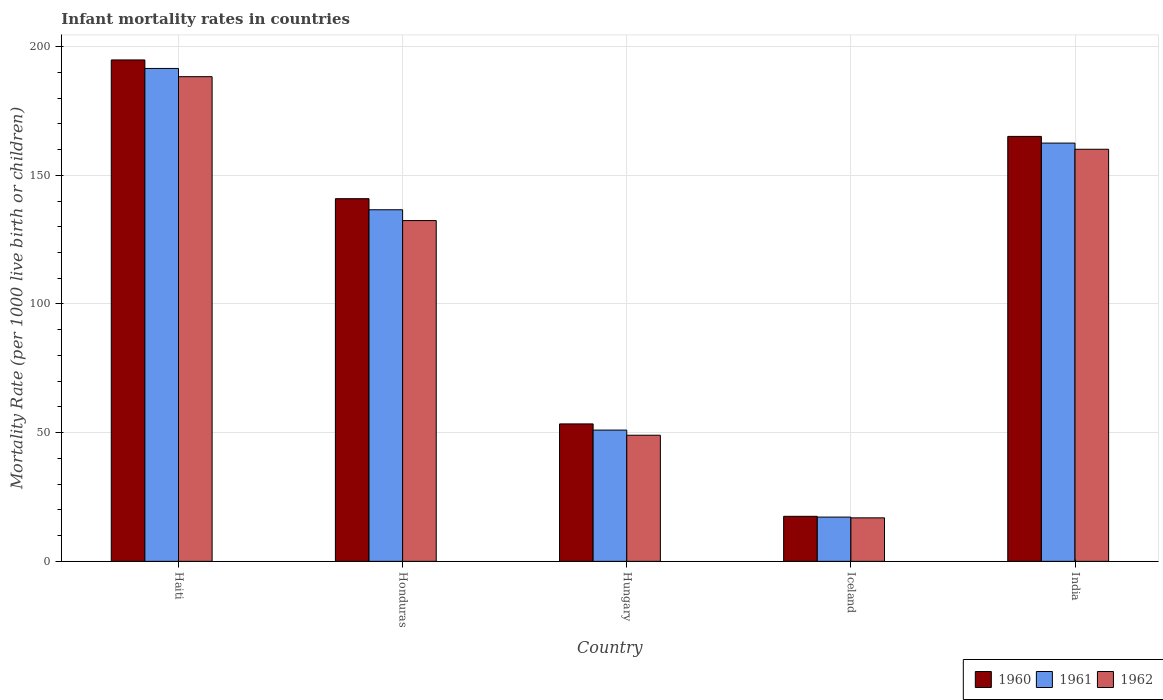How many groups of bars are there?
Offer a terse response. 5. Are the number of bars per tick equal to the number of legend labels?
Make the answer very short. Yes. Are the number of bars on each tick of the X-axis equal?
Ensure brevity in your answer.  Yes. How many bars are there on the 5th tick from the left?
Give a very brief answer. 3. What is the label of the 1st group of bars from the left?
Keep it short and to the point. Haiti. What is the infant mortality rate in 1961 in India?
Your answer should be very brief. 162.5. Across all countries, what is the maximum infant mortality rate in 1962?
Offer a very short reply. 188.3. In which country was the infant mortality rate in 1960 maximum?
Your answer should be compact. Haiti. In which country was the infant mortality rate in 1961 minimum?
Your response must be concise. Iceland. What is the total infant mortality rate in 1960 in the graph?
Your answer should be very brief. 571.7. What is the difference between the infant mortality rate in 1960 in Honduras and that in India?
Keep it short and to the point. -24.2. What is the difference between the infant mortality rate in 1960 in Hungary and the infant mortality rate in 1961 in Iceland?
Ensure brevity in your answer.  36.2. What is the average infant mortality rate in 1960 per country?
Make the answer very short. 114.34. What is the difference between the infant mortality rate of/in 1960 and infant mortality rate of/in 1961 in Hungary?
Make the answer very short. 2.4. In how many countries, is the infant mortality rate in 1961 greater than 70?
Ensure brevity in your answer.  3. What is the ratio of the infant mortality rate in 1961 in Haiti to that in Hungary?
Provide a succinct answer. 3.75. Is the infant mortality rate in 1962 in Hungary less than that in Iceland?
Provide a succinct answer. No. What is the difference between the highest and the second highest infant mortality rate in 1961?
Keep it short and to the point. -25.9. What is the difference between the highest and the lowest infant mortality rate in 1961?
Give a very brief answer. 174.3. Is the sum of the infant mortality rate in 1961 in Iceland and India greater than the maximum infant mortality rate in 1962 across all countries?
Keep it short and to the point. No. What does the 3rd bar from the left in Iceland represents?
Offer a very short reply. 1962. What does the 3rd bar from the right in Hungary represents?
Offer a very short reply. 1960. Is it the case that in every country, the sum of the infant mortality rate in 1961 and infant mortality rate in 1962 is greater than the infant mortality rate in 1960?
Your response must be concise. Yes. How many bars are there?
Your answer should be compact. 15. What is the difference between two consecutive major ticks on the Y-axis?
Make the answer very short. 50. Does the graph contain grids?
Provide a short and direct response. Yes. Where does the legend appear in the graph?
Make the answer very short. Bottom right. What is the title of the graph?
Offer a terse response. Infant mortality rates in countries. Does "2008" appear as one of the legend labels in the graph?
Keep it short and to the point. No. What is the label or title of the Y-axis?
Keep it short and to the point. Mortality Rate (per 1000 live birth or children). What is the Mortality Rate (per 1000 live birth or children) in 1960 in Haiti?
Your answer should be compact. 194.8. What is the Mortality Rate (per 1000 live birth or children) in 1961 in Haiti?
Ensure brevity in your answer.  191.5. What is the Mortality Rate (per 1000 live birth or children) of 1962 in Haiti?
Provide a short and direct response. 188.3. What is the Mortality Rate (per 1000 live birth or children) in 1960 in Honduras?
Provide a short and direct response. 140.9. What is the Mortality Rate (per 1000 live birth or children) of 1961 in Honduras?
Give a very brief answer. 136.6. What is the Mortality Rate (per 1000 live birth or children) in 1962 in Honduras?
Offer a very short reply. 132.4. What is the Mortality Rate (per 1000 live birth or children) in 1960 in Hungary?
Ensure brevity in your answer.  53.4. What is the Mortality Rate (per 1000 live birth or children) in 1961 in Hungary?
Ensure brevity in your answer.  51. What is the Mortality Rate (per 1000 live birth or children) in 1962 in Hungary?
Your answer should be very brief. 49. What is the Mortality Rate (per 1000 live birth or children) in 1960 in Iceland?
Provide a succinct answer. 17.5. What is the Mortality Rate (per 1000 live birth or children) in 1961 in Iceland?
Ensure brevity in your answer.  17.2. What is the Mortality Rate (per 1000 live birth or children) of 1962 in Iceland?
Your response must be concise. 16.9. What is the Mortality Rate (per 1000 live birth or children) in 1960 in India?
Your answer should be compact. 165.1. What is the Mortality Rate (per 1000 live birth or children) of 1961 in India?
Ensure brevity in your answer.  162.5. What is the Mortality Rate (per 1000 live birth or children) of 1962 in India?
Your answer should be compact. 160.1. Across all countries, what is the maximum Mortality Rate (per 1000 live birth or children) of 1960?
Offer a terse response. 194.8. Across all countries, what is the maximum Mortality Rate (per 1000 live birth or children) in 1961?
Make the answer very short. 191.5. Across all countries, what is the maximum Mortality Rate (per 1000 live birth or children) of 1962?
Offer a very short reply. 188.3. Across all countries, what is the minimum Mortality Rate (per 1000 live birth or children) in 1960?
Provide a short and direct response. 17.5. Across all countries, what is the minimum Mortality Rate (per 1000 live birth or children) of 1961?
Provide a succinct answer. 17.2. Across all countries, what is the minimum Mortality Rate (per 1000 live birth or children) in 1962?
Keep it short and to the point. 16.9. What is the total Mortality Rate (per 1000 live birth or children) in 1960 in the graph?
Keep it short and to the point. 571.7. What is the total Mortality Rate (per 1000 live birth or children) of 1961 in the graph?
Keep it short and to the point. 558.8. What is the total Mortality Rate (per 1000 live birth or children) of 1962 in the graph?
Keep it short and to the point. 546.7. What is the difference between the Mortality Rate (per 1000 live birth or children) of 1960 in Haiti and that in Honduras?
Make the answer very short. 53.9. What is the difference between the Mortality Rate (per 1000 live birth or children) in 1961 in Haiti and that in Honduras?
Make the answer very short. 54.9. What is the difference between the Mortality Rate (per 1000 live birth or children) in 1962 in Haiti and that in Honduras?
Your answer should be very brief. 55.9. What is the difference between the Mortality Rate (per 1000 live birth or children) of 1960 in Haiti and that in Hungary?
Offer a very short reply. 141.4. What is the difference between the Mortality Rate (per 1000 live birth or children) in 1961 in Haiti and that in Hungary?
Provide a succinct answer. 140.5. What is the difference between the Mortality Rate (per 1000 live birth or children) of 1962 in Haiti and that in Hungary?
Offer a very short reply. 139.3. What is the difference between the Mortality Rate (per 1000 live birth or children) in 1960 in Haiti and that in Iceland?
Keep it short and to the point. 177.3. What is the difference between the Mortality Rate (per 1000 live birth or children) in 1961 in Haiti and that in Iceland?
Give a very brief answer. 174.3. What is the difference between the Mortality Rate (per 1000 live birth or children) of 1962 in Haiti and that in Iceland?
Provide a short and direct response. 171.4. What is the difference between the Mortality Rate (per 1000 live birth or children) in 1960 in Haiti and that in India?
Offer a terse response. 29.7. What is the difference between the Mortality Rate (per 1000 live birth or children) of 1961 in Haiti and that in India?
Offer a terse response. 29. What is the difference between the Mortality Rate (per 1000 live birth or children) in 1962 in Haiti and that in India?
Your answer should be compact. 28.2. What is the difference between the Mortality Rate (per 1000 live birth or children) in 1960 in Honduras and that in Hungary?
Offer a terse response. 87.5. What is the difference between the Mortality Rate (per 1000 live birth or children) in 1961 in Honduras and that in Hungary?
Your answer should be compact. 85.6. What is the difference between the Mortality Rate (per 1000 live birth or children) in 1962 in Honduras and that in Hungary?
Keep it short and to the point. 83.4. What is the difference between the Mortality Rate (per 1000 live birth or children) of 1960 in Honduras and that in Iceland?
Make the answer very short. 123.4. What is the difference between the Mortality Rate (per 1000 live birth or children) in 1961 in Honduras and that in Iceland?
Give a very brief answer. 119.4. What is the difference between the Mortality Rate (per 1000 live birth or children) of 1962 in Honduras and that in Iceland?
Keep it short and to the point. 115.5. What is the difference between the Mortality Rate (per 1000 live birth or children) in 1960 in Honduras and that in India?
Offer a terse response. -24.2. What is the difference between the Mortality Rate (per 1000 live birth or children) of 1961 in Honduras and that in India?
Your answer should be compact. -25.9. What is the difference between the Mortality Rate (per 1000 live birth or children) of 1962 in Honduras and that in India?
Ensure brevity in your answer.  -27.7. What is the difference between the Mortality Rate (per 1000 live birth or children) of 1960 in Hungary and that in Iceland?
Ensure brevity in your answer.  35.9. What is the difference between the Mortality Rate (per 1000 live birth or children) of 1961 in Hungary and that in Iceland?
Ensure brevity in your answer.  33.8. What is the difference between the Mortality Rate (per 1000 live birth or children) of 1962 in Hungary and that in Iceland?
Give a very brief answer. 32.1. What is the difference between the Mortality Rate (per 1000 live birth or children) of 1960 in Hungary and that in India?
Your answer should be compact. -111.7. What is the difference between the Mortality Rate (per 1000 live birth or children) of 1961 in Hungary and that in India?
Your answer should be very brief. -111.5. What is the difference between the Mortality Rate (per 1000 live birth or children) of 1962 in Hungary and that in India?
Ensure brevity in your answer.  -111.1. What is the difference between the Mortality Rate (per 1000 live birth or children) in 1960 in Iceland and that in India?
Keep it short and to the point. -147.6. What is the difference between the Mortality Rate (per 1000 live birth or children) in 1961 in Iceland and that in India?
Give a very brief answer. -145.3. What is the difference between the Mortality Rate (per 1000 live birth or children) in 1962 in Iceland and that in India?
Provide a succinct answer. -143.2. What is the difference between the Mortality Rate (per 1000 live birth or children) of 1960 in Haiti and the Mortality Rate (per 1000 live birth or children) of 1961 in Honduras?
Give a very brief answer. 58.2. What is the difference between the Mortality Rate (per 1000 live birth or children) in 1960 in Haiti and the Mortality Rate (per 1000 live birth or children) in 1962 in Honduras?
Make the answer very short. 62.4. What is the difference between the Mortality Rate (per 1000 live birth or children) in 1961 in Haiti and the Mortality Rate (per 1000 live birth or children) in 1962 in Honduras?
Offer a very short reply. 59.1. What is the difference between the Mortality Rate (per 1000 live birth or children) in 1960 in Haiti and the Mortality Rate (per 1000 live birth or children) in 1961 in Hungary?
Offer a very short reply. 143.8. What is the difference between the Mortality Rate (per 1000 live birth or children) in 1960 in Haiti and the Mortality Rate (per 1000 live birth or children) in 1962 in Hungary?
Your answer should be very brief. 145.8. What is the difference between the Mortality Rate (per 1000 live birth or children) in 1961 in Haiti and the Mortality Rate (per 1000 live birth or children) in 1962 in Hungary?
Offer a terse response. 142.5. What is the difference between the Mortality Rate (per 1000 live birth or children) of 1960 in Haiti and the Mortality Rate (per 1000 live birth or children) of 1961 in Iceland?
Make the answer very short. 177.6. What is the difference between the Mortality Rate (per 1000 live birth or children) in 1960 in Haiti and the Mortality Rate (per 1000 live birth or children) in 1962 in Iceland?
Keep it short and to the point. 177.9. What is the difference between the Mortality Rate (per 1000 live birth or children) of 1961 in Haiti and the Mortality Rate (per 1000 live birth or children) of 1962 in Iceland?
Your answer should be compact. 174.6. What is the difference between the Mortality Rate (per 1000 live birth or children) of 1960 in Haiti and the Mortality Rate (per 1000 live birth or children) of 1961 in India?
Provide a succinct answer. 32.3. What is the difference between the Mortality Rate (per 1000 live birth or children) in 1960 in Haiti and the Mortality Rate (per 1000 live birth or children) in 1962 in India?
Provide a short and direct response. 34.7. What is the difference between the Mortality Rate (per 1000 live birth or children) of 1961 in Haiti and the Mortality Rate (per 1000 live birth or children) of 1962 in India?
Give a very brief answer. 31.4. What is the difference between the Mortality Rate (per 1000 live birth or children) of 1960 in Honduras and the Mortality Rate (per 1000 live birth or children) of 1961 in Hungary?
Provide a succinct answer. 89.9. What is the difference between the Mortality Rate (per 1000 live birth or children) of 1960 in Honduras and the Mortality Rate (per 1000 live birth or children) of 1962 in Hungary?
Your answer should be compact. 91.9. What is the difference between the Mortality Rate (per 1000 live birth or children) of 1961 in Honduras and the Mortality Rate (per 1000 live birth or children) of 1962 in Hungary?
Give a very brief answer. 87.6. What is the difference between the Mortality Rate (per 1000 live birth or children) in 1960 in Honduras and the Mortality Rate (per 1000 live birth or children) in 1961 in Iceland?
Offer a very short reply. 123.7. What is the difference between the Mortality Rate (per 1000 live birth or children) of 1960 in Honduras and the Mortality Rate (per 1000 live birth or children) of 1962 in Iceland?
Provide a succinct answer. 124. What is the difference between the Mortality Rate (per 1000 live birth or children) of 1961 in Honduras and the Mortality Rate (per 1000 live birth or children) of 1962 in Iceland?
Ensure brevity in your answer.  119.7. What is the difference between the Mortality Rate (per 1000 live birth or children) in 1960 in Honduras and the Mortality Rate (per 1000 live birth or children) in 1961 in India?
Your answer should be compact. -21.6. What is the difference between the Mortality Rate (per 1000 live birth or children) in 1960 in Honduras and the Mortality Rate (per 1000 live birth or children) in 1962 in India?
Your answer should be compact. -19.2. What is the difference between the Mortality Rate (per 1000 live birth or children) in 1961 in Honduras and the Mortality Rate (per 1000 live birth or children) in 1962 in India?
Make the answer very short. -23.5. What is the difference between the Mortality Rate (per 1000 live birth or children) of 1960 in Hungary and the Mortality Rate (per 1000 live birth or children) of 1961 in Iceland?
Your response must be concise. 36.2. What is the difference between the Mortality Rate (per 1000 live birth or children) of 1960 in Hungary and the Mortality Rate (per 1000 live birth or children) of 1962 in Iceland?
Your answer should be very brief. 36.5. What is the difference between the Mortality Rate (per 1000 live birth or children) of 1961 in Hungary and the Mortality Rate (per 1000 live birth or children) of 1962 in Iceland?
Your response must be concise. 34.1. What is the difference between the Mortality Rate (per 1000 live birth or children) in 1960 in Hungary and the Mortality Rate (per 1000 live birth or children) in 1961 in India?
Your response must be concise. -109.1. What is the difference between the Mortality Rate (per 1000 live birth or children) in 1960 in Hungary and the Mortality Rate (per 1000 live birth or children) in 1962 in India?
Your answer should be very brief. -106.7. What is the difference between the Mortality Rate (per 1000 live birth or children) in 1961 in Hungary and the Mortality Rate (per 1000 live birth or children) in 1962 in India?
Provide a short and direct response. -109.1. What is the difference between the Mortality Rate (per 1000 live birth or children) in 1960 in Iceland and the Mortality Rate (per 1000 live birth or children) in 1961 in India?
Your answer should be compact. -145. What is the difference between the Mortality Rate (per 1000 live birth or children) in 1960 in Iceland and the Mortality Rate (per 1000 live birth or children) in 1962 in India?
Your answer should be compact. -142.6. What is the difference between the Mortality Rate (per 1000 live birth or children) of 1961 in Iceland and the Mortality Rate (per 1000 live birth or children) of 1962 in India?
Offer a very short reply. -142.9. What is the average Mortality Rate (per 1000 live birth or children) of 1960 per country?
Give a very brief answer. 114.34. What is the average Mortality Rate (per 1000 live birth or children) in 1961 per country?
Offer a very short reply. 111.76. What is the average Mortality Rate (per 1000 live birth or children) of 1962 per country?
Provide a succinct answer. 109.34. What is the difference between the Mortality Rate (per 1000 live birth or children) of 1961 and Mortality Rate (per 1000 live birth or children) of 1962 in Haiti?
Make the answer very short. 3.2. What is the difference between the Mortality Rate (per 1000 live birth or children) in 1960 and Mortality Rate (per 1000 live birth or children) in 1961 in Hungary?
Your answer should be compact. 2.4. What is the difference between the Mortality Rate (per 1000 live birth or children) of 1960 and Mortality Rate (per 1000 live birth or children) of 1962 in Hungary?
Your answer should be very brief. 4.4. What is the difference between the Mortality Rate (per 1000 live birth or children) in 1960 and Mortality Rate (per 1000 live birth or children) in 1961 in Iceland?
Provide a succinct answer. 0.3. What is the difference between the Mortality Rate (per 1000 live birth or children) in 1961 and Mortality Rate (per 1000 live birth or children) in 1962 in Iceland?
Make the answer very short. 0.3. What is the difference between the Mortality Rate (per 1000 live birth or children) in 1960 and Mortality Rate (per 1000 live birth or children) in 1962 in India?
Offer a very short reply. 5. What is the ratio of the Mortality Rate (per 1000 live birth or children) in 1960 in Haiti to that in Honduras?
Keep it short and to the point. 1.38. What is the ratio of the Mortality Rate (per 1000 live birth or children) in 1961 in Haiti to that in Honduras?
Offer a very short reply. 1.4. What is the ratio of the Mortality Rate (per 1000 live birth or children) of 1962 in Haiti to that in Honduras?
Provide a short and direct response. 1.42. What is the ratio of the Mortality Rate (per 1000 live birth or children) of 1960 in Haiti to that in Hungary?
Keep it short and to the point. 3.65. What is the ratio of the Mortality Rate (per 1000 live birth or children) of 1961 in Haiti to that in Hungary?
Keep it short and to the point. 3.75. What is the ratio of the Mortality Rate (per 1000 live birth or children) of 1962 in Haiti to that in Hungary?
Ensure brevity in your answer.  3.84. What is the ratio of the Mortality Rate (per 1000 live birth or children) of 1960 in Haiti to that in Iceland?
Ensure brevity in your answer.  11.13. What is the ratio of the Mortality Rate (per 1000 live birth or children) in 1961 in Haiti to that in Iceland?
Offer a terse response. 11.13. What is the ratio of the Mortality Rate (per 1000 live birth or children) in 1962 in Haiti to that in Iceland?
Keep it short and to the point. 11.14. What is the ratio of the Mortality Rate (per 1000 live birth or children) of 1960 in Haiti to that in India?
Keep it short and to the point. 1.18. What is the ratio of the Mortality Rate (per 1000 live birth or children) of 1961 in Haiti to that in India?
Give a very brief answer. 1.18. What is the ratio of the Mortality Rate (per 1000 live birth or children) of 1962 in Haiti to that in India?
Your answer should be compact. 1.18. What is the ratio of the Mortality Rate (per 1000 live birth or children) in 1960 in Honduras to that in Hungary?
Offer a terse response. 2.64. What is the ratio of the Mortality Rate (per 1000 live birth or children) of 1961 in Honduras to that in Hungary?
Keep it short and to the point. 2.68. What is the ratio of the Mortality Rate (per 1000 live birth or children) of 1962 in Honduras to that in Hungary?
Your answer should be very brief. 2.7. What is the ratio of the Mortality Rate (per 1000 live birth or children) of 1960 in Honduras to that in Iceland?
Your answer should be very brief. 8.05. What is the ratio of the Mortality Rate (per 1000 live birth or children) of 1961 in Honduras to that in Iceland?
Offer a very short reply. 7.94. What is the ratio of the Mortality Rate (per 1000 live birth or children) of 1962 in Honduras to that in Iceland?
Make the answer very short. 7.83. What is the ratio of the Mortality Rate (per 1000 live birth or children) of 1960 in Honduras to that in India?
Keep it short and to the point. 0.85. What is the ratio of the Mortality Rate (per 1000 live birth or children) of 1961 in Honduras to that in India?
Provide a short and direct response. 0.84. What is the ratio of the Mortality Rate (per 1000 live birth or children) of 1962 in Honduras to that in India?
Offer a very short reply. 0.83. What is the ratio of the Mortality Rate (per 1000 live birth or children) of 1960 in Hungary to that in Iceland?
Give a very brief answer. 3.05. What is the ratio of the Mortality Rate (per 1000 live birth or children) in 1961 in Hungary to that in Iceland?
Your response must be concise. 2.97. What is the ratio of the Mortality Rate (per 1000 live birth or children) of 1962 in Hungary to that in Iceland?
Your answer should be compact. 2.9. What is the ratio of the Mortality Rate (per 1000 live birth or children) of 1960 in Hungary to that in India?
Your answer should be very brief. 0.32. What is the ratio of the Mortality Rate (per 1000 live birth or children) in 1961 in Hungary to that in India?
Your response must be concise. 0.31. What is the ratio of the Mortality Rate (per 1000 live birth or children) of 1962 in Hungary to that in India?
Offer a very short reply. 0.31. What is the ratio of the Mortality Rate (per 1000 live birth or children) of 1960 in Iceland to that in India?
Your answer should be compact. 0.11. What is the ratio of the Mortality Rate (per 1000 live birth or children) of 1961 in Iceland to that in India?
Your answer should be very brief. 0.11. What is the ratio of the Mortality Rate (per 1000 live birth or children) in 1962 in Iceland to that in India?
Your answer should be compact. 0.11. What is the difference between the highest and the second highest Mortality Rate (per 1000 live birth or children) of 1960?
Make the answer very short. 29.7. What is the difference between the highest and the second highest Mortality Rate (per 1000 live birth or children) of 1961?
Offer a very short reply. 29. What is the difference between the highest and the second highest Mortality Rate (per 1000 live birth or children) in 1962?
Ensure brevity in your answer.  28.2. What is the difference between the highest and the lowest Mortality Rate (per 1000 live birth or children) in 1960?
Keep it short and to the point. 177.3. What is the difference between the highest and the lowest Mortality Rate (per 1000 live birth or children) of 1961?
Make the answer very short. 174.3. What is the difference between the highest and the lowest Mortality Rate (per 1000 live birth or children) in 1962?
Give a very brief answer. 171.4. 